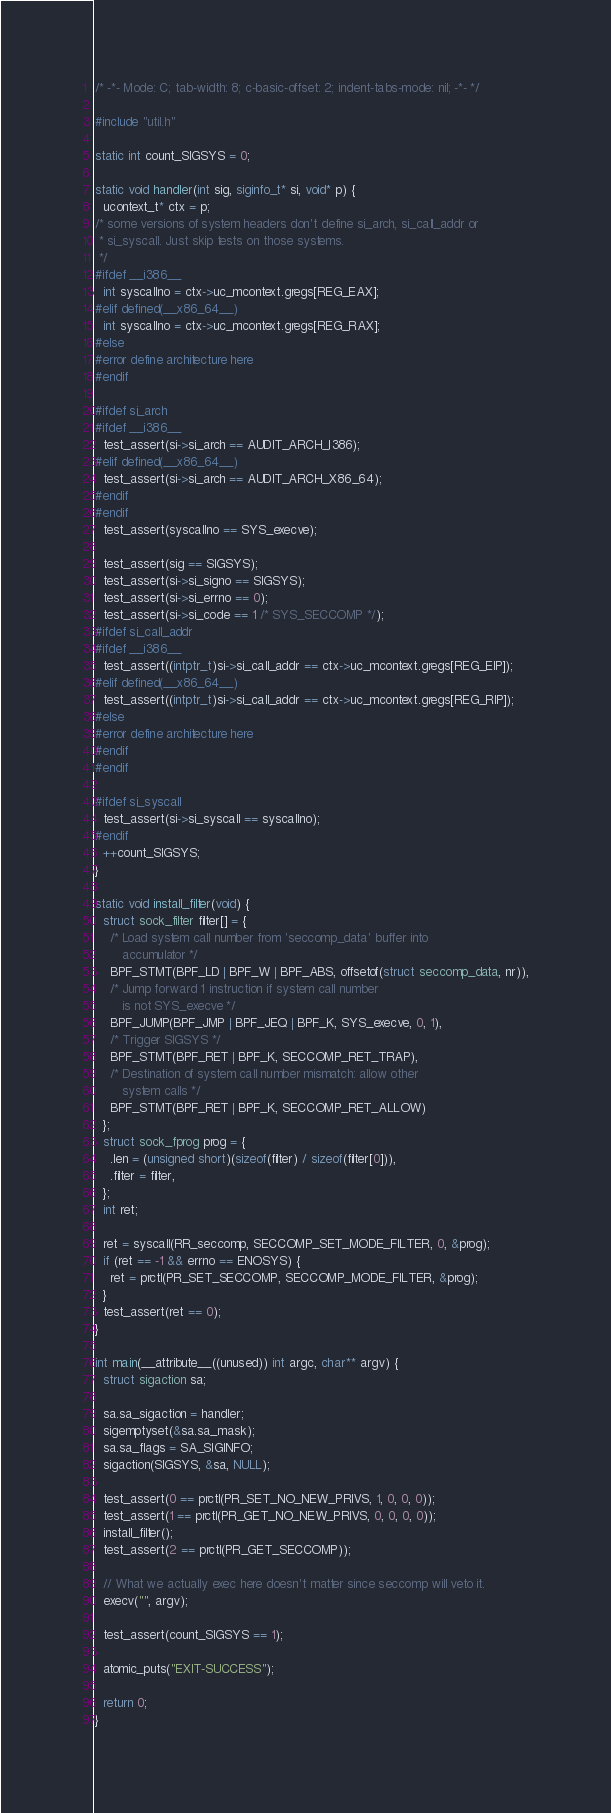Convert code to text. <code><loc_0><loc_0><loc_500><loc_500><_C_>/* -*- Mode: C; tab-width: 8; c-basic-offset: 2; indent-tabs-mode: nil; -*- */

#include "util.h"

static int count_SIGSYS = 0;

static void handler(int sig, siginfo_t* si, void* p) {
  ucontext_t* ctx = p;
/* some versions of system headers don't define si_arch, si_call_addr or
 * si_syscall. Just skip tests on those systems.
 */
#ifdef __i386__
  int syscallno = ctx->uc_mcontext.gregs[REG_EAX];
#elif defined(__x86_64__)
  int syscallno = ctx->uc_mcontext.gregs[REG_RAX];
#else
#error define architecture here
#endif

#ifdef si_arch
#ifdef __i386__
  test_assert(si->si_arch == AUDIT_ARCH_I386);
#elif defined(__x86_64__)
  test_assert(si->si_arch == AUDIT_ARCH_X86_64);
#endif
#endif
  test_assert(syscallno == SYS_execve);

  test_assert(sig == SIGSYS);
  test_assert(si->si_signo == SIGSYS);
  test_assert(si->si_errno == 0);
  test_assert(si->si_code == 1 /* SYS_SECCOMP */);
#ifdef si_call_addr
#ifdef __i386__
  test_assert((intptr_t)si->si_call_addr == ctx->uc_mcontext.gregs[REG_EIP]);
#elif defined(__x86_64__)
  test_assert((intptr_t)si->si_call_addr == ctx->uc_mcontext.gregs[REG_RIP]);
#else
#error define architecture here
#endif
#endif

#ifdef si_syscall
  test_assert(si->si_syscall == syscallno);
#endif
  ++count_SIGSYS;
}

static void install_filter(void) {
  struct sock_filter filter[] = {
    /* Load system call number from 'seccomp_data' buffer into
       accumulator */
    BPF_STMT(BPF_LD | BPF_W | BPF_ABS, offsetof(struct seccomp_data, nr)),
    /* Jump forward 1 instruction if system call number
       is not SYS_execve */
    BPF_JUMP(BPF_JMP | BPF_JEQ | BPF_K, SYS_execve, 0, 1),
    /* Trigger SIGSYS */
    BPF_STMT(BPF_RET | BPF_K, SECCOMP_RET_TRAP),
    /* Destination of system call number mismatch: allow other
       system calls */
    BPF_STMT(BPF_RET | BPF_K, SECCOMP_RET_ALLOW)
  };
  struct sock_fprog prog = {
    .len = (unsigned short)(sizeof(filter) / sizeof(filter[0])),
    .filter = filter,
  };
  int ret;

  ret = syscall(RR_seccomp, SECCOMP_SET_MODE_FILTER, 0, &prog);
  if (ret == -1 && errno == ENOSYS) {
    ret = prctl(PR_SET_SECCOMP, SECCOMP_MODE_FILTER, &prog);
  }
  test_assert(ret == 0);
}

int main(__attribute__((unused)) int argc, char** argv) {
  struct sigaction sa;

  sa.sa_sigaction = handler;
  sigemptyset(&sa.sa_mask);
  sa.sa_flags = SA_SIGINFO;
  sigaction(SIGSYS, &sa, NULL);

  test_assert(0 == prctl(PR_SET_NO_NEW_PRIVS, 1, 0, 0, 0));
  test_assert(1 == prctl(PR_GET_NO_NEW_PRIVS, 0, 0, 0, 0));
  install_filter();
  test_assert(2 == prctl(PR_GET_SECCOMP));

  // What we actually exec here doesn't matter since seccomp will veto it.
  execv("", argv);

  test_assert(count_SIGSYS == 1);

  atomic_puts("EXIT-SUCCESS");

  return 0;
}
</code> 